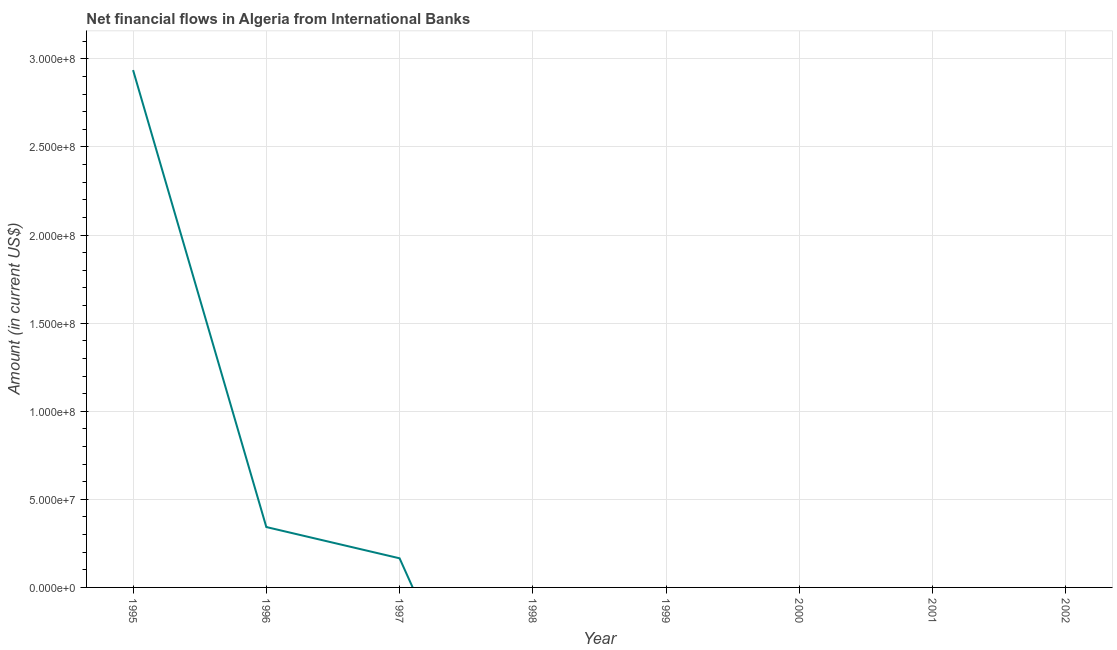What is the net financial flows from ibrd in 2000?
Your answer should be compact. 0. Across all years, what is the maximum net financial flows from ibrd?
Keep it short and to the point. 2.94e+08. In which year was the net financial flows from ibrd maximum?
Provide a succinct answer. 1995. What is the sum of the net financial flows from ibrd?
Offer a very short reply. 3.44e+08. What is the average net financial flows from ibrd per year?
Ensure brevity in your answer.  4.31e+07. What is the difference between the highest and the second highest net financial flows from ibrd?
Your answer should be very brief. 2.59e+08. What is the difference between the highest and the lowest net financial flows from ibrd?
Provide a succinct answer. 2.94e+08. Does the net financial flows from ibrd monotonically increase over the years?
Offer a very short reply. No. How many lines are there?
Give a very brief answer. 1. How many years are there in the graph?
Your answer should be very brief. 8. What is the difference between two consecutive major ticks on the Y-axis?
Make the answer very short. 5.00e+07. Does the graph contain any zero values?
Provide a succinct answer. Yes. Does the graph contain grids?
Offer a terse response. Yes. What is the title of the graph?
Offer a terse response. Net financial flows in Algeria from International Banks. What is the Amount (in current US$) in 1995?
Give a very brief answer. 2.94e+08. What is the Amount (in current US$) in 1996?
Give a very brief answer. 3.43e+07. What is the Amount (in current US$) of 1997?
Make the answer very short. 1.65e+07. What is the Amount (in current US$) of 1998?
Offer a terse response. 0. What is the Amount (in current US$) in 1999?
Offer a very short reply. 0. What is the difference between the Amount (in current US$) in 1995 and 1996?
Keep it short and to the point. 2.59e+08. What is the difference between the Amount (in current US$) in 1995 and 1997?
Provide a succinct answer. 2.77e+08. What is the difference between the Amount (in current US$) in 1996 and 1997?
Your response must be concise. 1.77e+07. What is the ratio of the Amount (in current US$) in 1995 to that in 1996?
Your answer should be very brief. 8.57. What is the ratio of the Amount (in current US$) in 1995 to that in 1997?
Provide a short and direct response. 17.76. What is the ratio of the Amount (in current US$) in 1996 to that in 1997?
Offer a terse response. 2.07. 